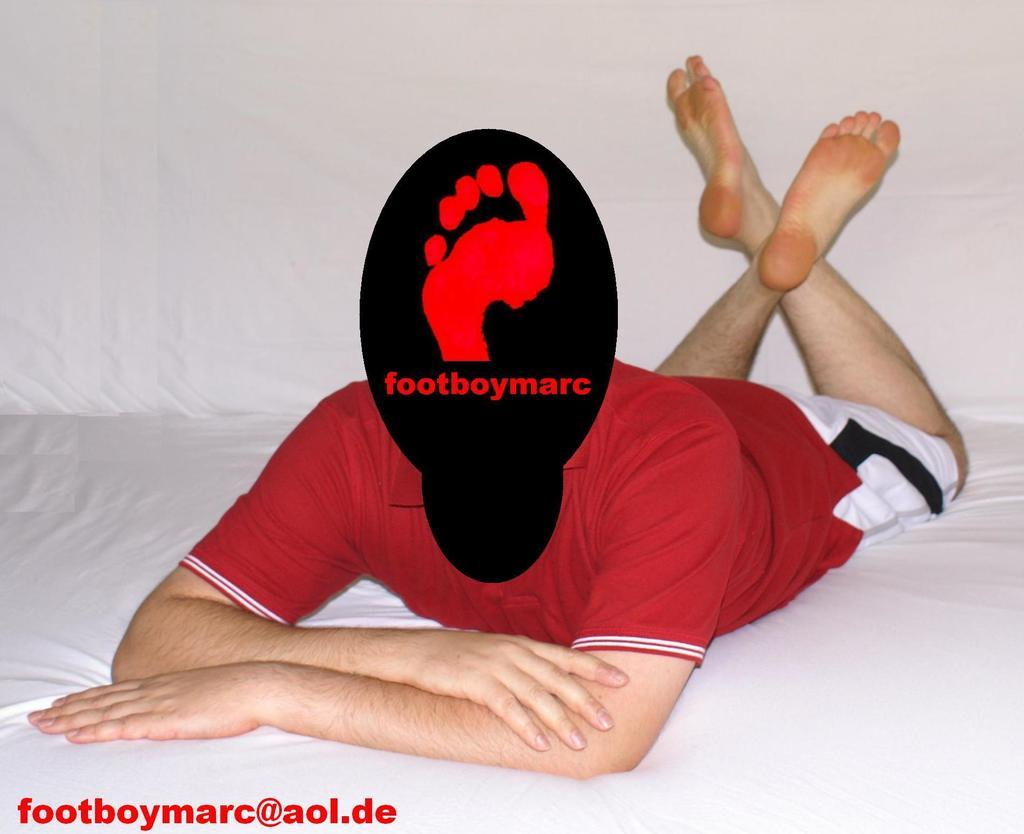Provide a one-sentence caption for the provided image. Young man laying on a bed with a black and red spot over his face that says "footboymarc" and directs viewers to visit foodboymarc@aol.de. 